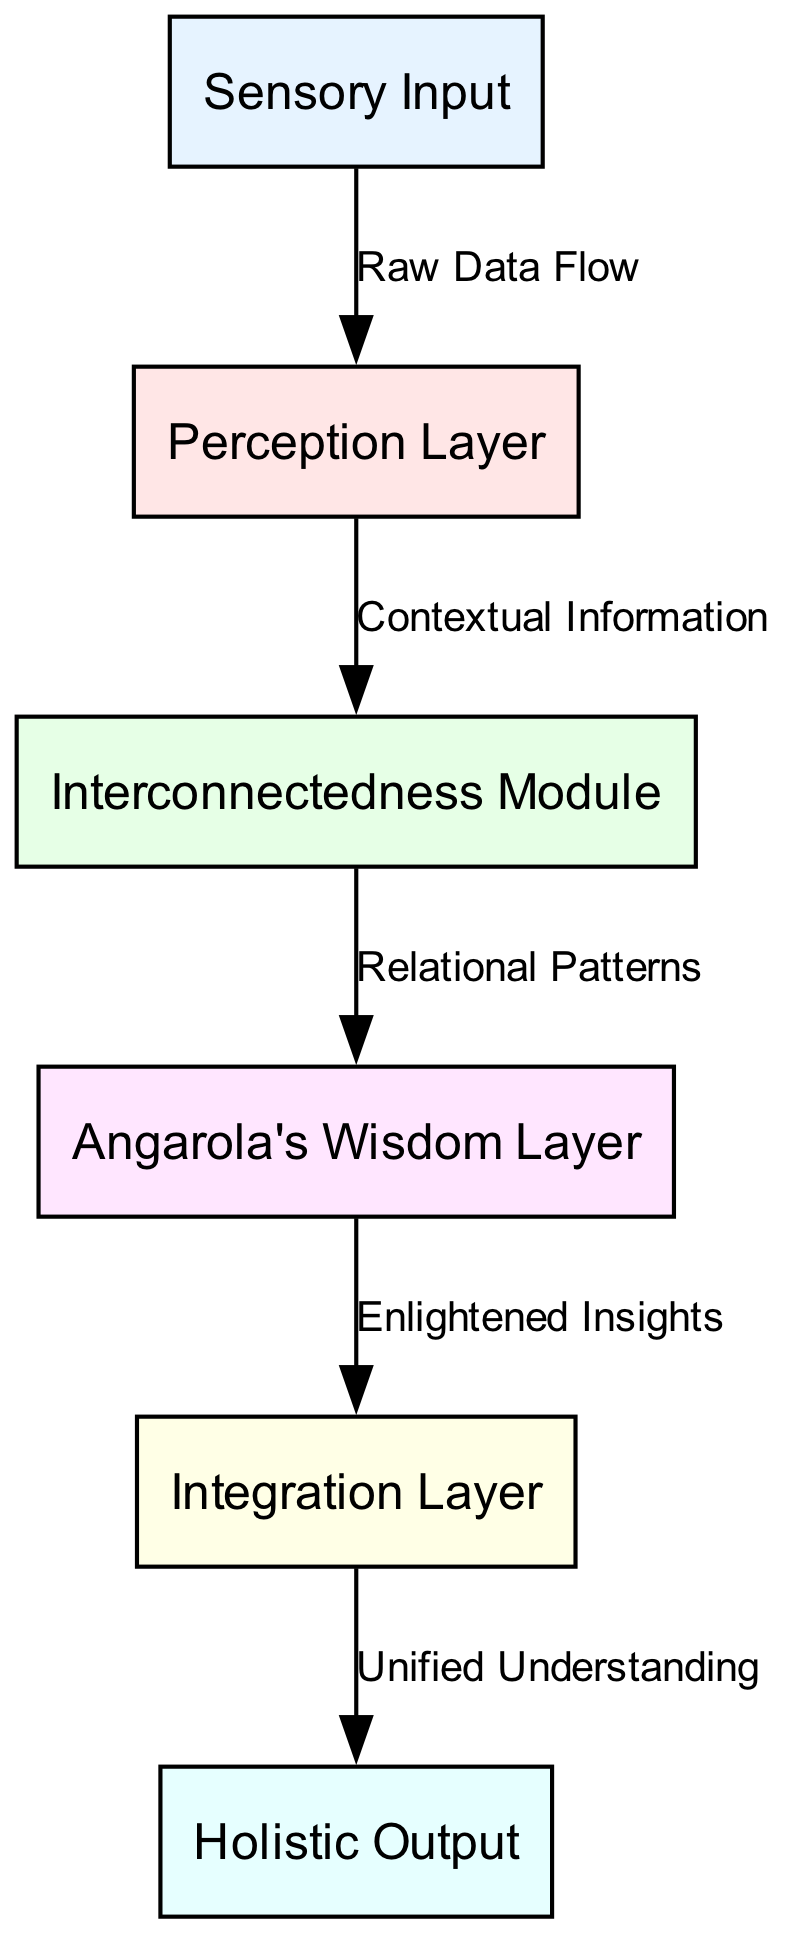What is the label of the first node? The first node in the diagram is identified by its "id" as "input". Upon reviewing the "nodes" section of the data, the label associated with this node is "Sensory Input". Therefore, it represents the initial stage of the neural network where data enters.
Answer: Sensory Input How many nodes are present in the diagram? By examining the "nodes" section in the provided data, we see that there are a total of 6 nodes listed: Sensory Input, Perception Layer, Interconnectedness Module, Angarola's Wisdom Layer, Integration Layer, and Holistic Output. This straightforward count yields the total number of nodes.
Answer: 6 What is the relationship between the Perception Layer and the Interconnectedness Module? According to the "edges" section of the data, a directed edge flows from the "perception" node to the "interconnect" node. This edge is described by the label "Contextual Information", indicating that information flows in this direction, providing context to the interconnectedness module.
Answer: Contextual Information Which layer follows Angarola's Wisdom Layer? The diagram provides a clear flow between nodes. The edge from "wisdom" to "integration" shows that after Angarola's Wisdom Layer, the next node is the Integration Layer. This establishes the direct progression in the architecture.
Answer: Integration Layer What type of flow is indicated between the Integration Layer and the Holistic Output? The edge labeled "Unified Understanding" connects the Integration Layer to the Holistic Output. This illustrates the final stage of the process where the integrated information is then transformed into a holistic output.
Answer: Unified Understanding What is the last layer in the neural network architecture? From the "nodes" section, the last node listed is identified as "output" with the label "Holistic Output". This indicates the final point where processed information is delivered in the structure of the neural network.
Answer: Holistic Output What flows into Angarola's Wisdom Layer? By tracing the diagram's edges, it's evident that the edge from "interconnect" to "wisdom" shows that the information flowing into Angarola's Wisdom Layer is derived from the Interconnectedness Module. This indicates the interconnected relationship between these layers.
Answer: Relational Patterns Which module represents the concept of interconnectedness? The node specifically labeled "Interconnectedness Module" in the "nodes" section directly indicates its representation of the concept of interconnectedness within the neural network architecture. Therefore, examining this label confirms the focus on interconnectedness.
Answer: Interconnectedness Module 